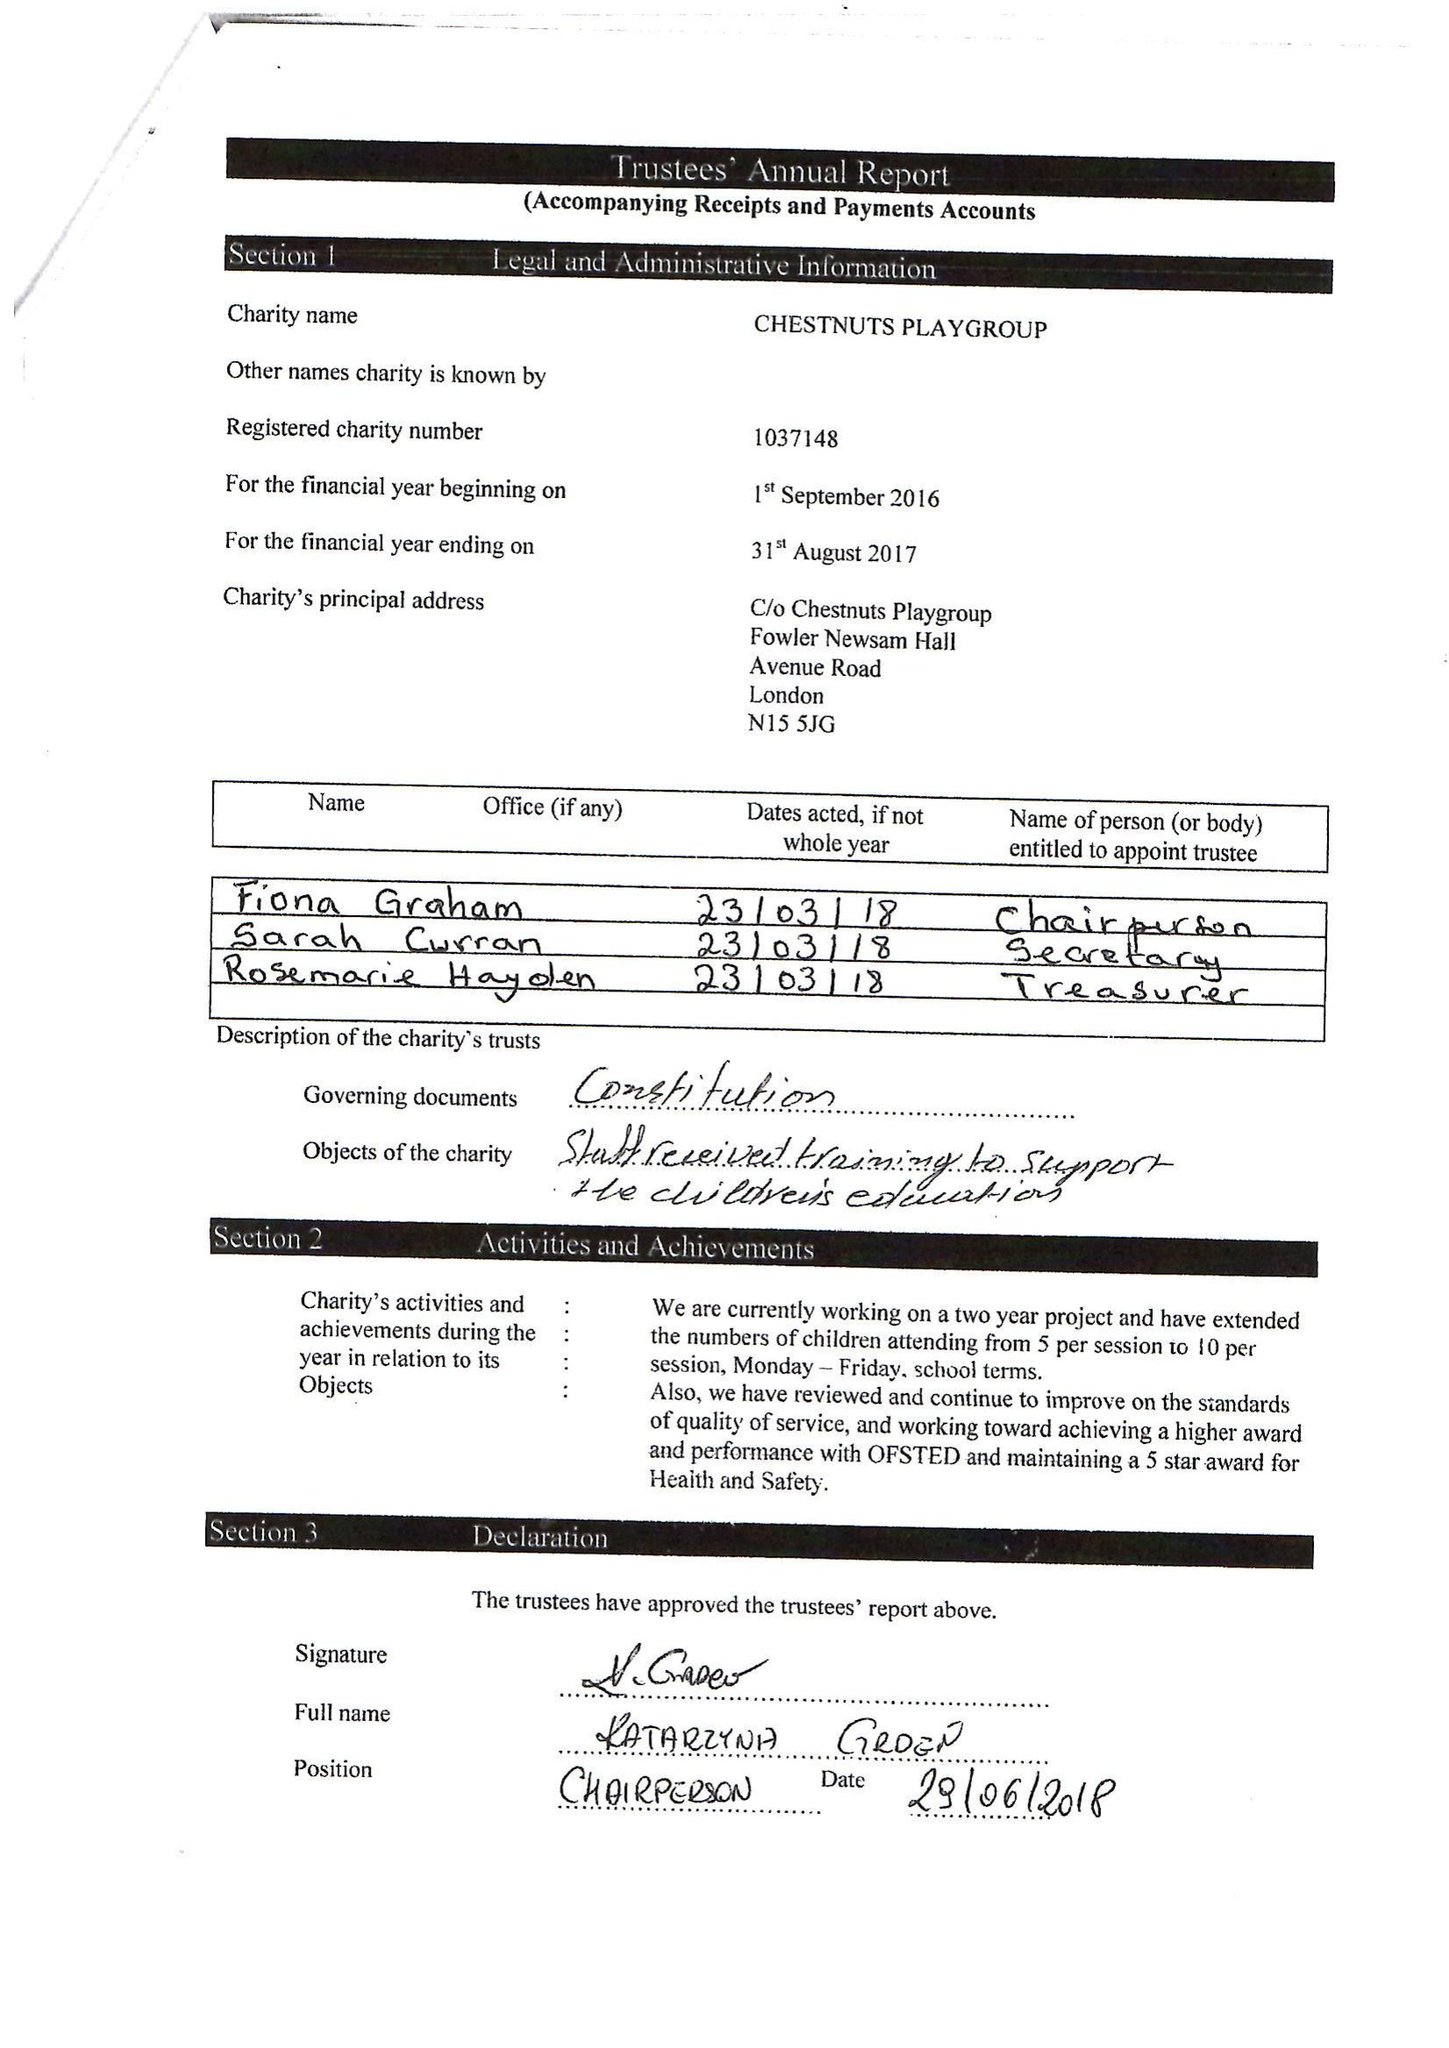What is the value for the report_date?
Answer the question using a single word or phrase. 2017-08-31 